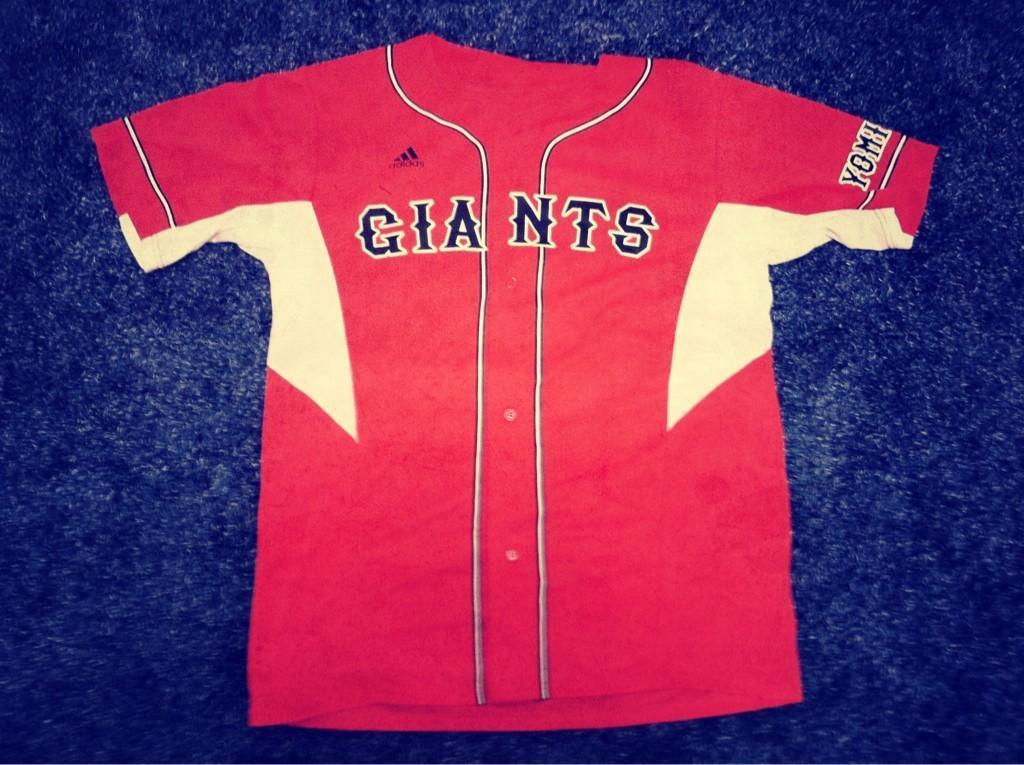<image>
Summarize the visual content of the image. A red Giants shirt on a blue background. 